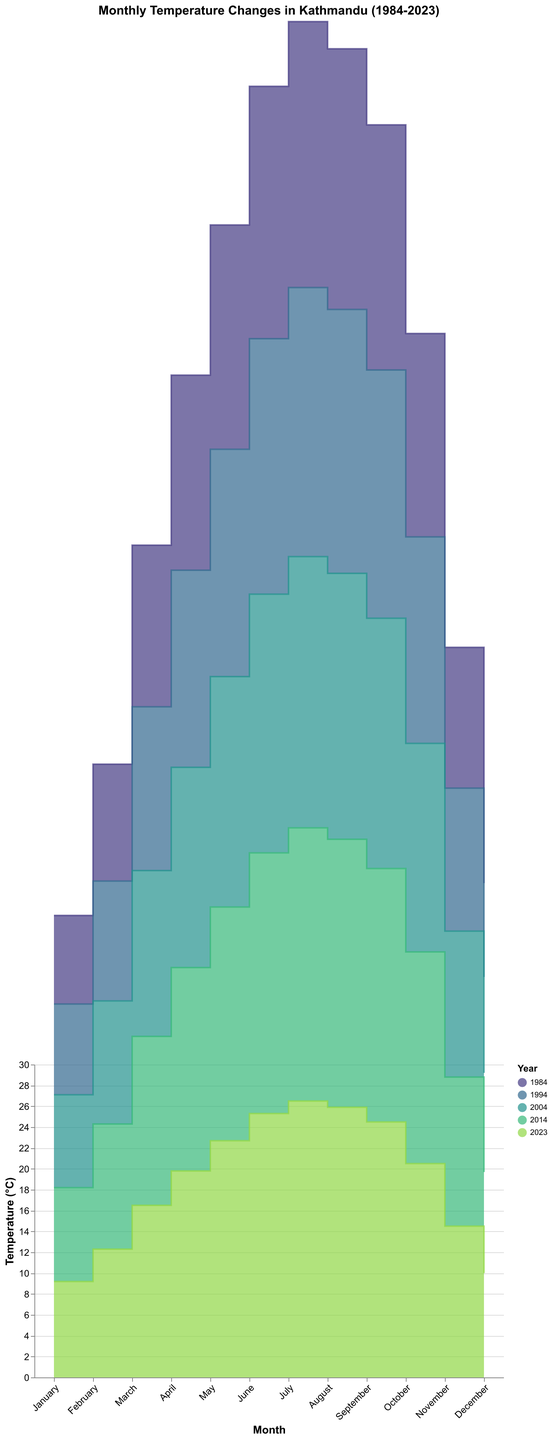What is the title of the figure? The title is visible at the top of the chart and is written in bold, indicating the main theme of the figure. The title reads "Monthly Temperature Changes in Kathmandu (1984-2023)".
Answer: Monthly Temperature Changes in Kathmandu (1984-2023) Which month in 2023 had the highest average temperature? By visually inspecting the step area for the year 2023 and looking for the peak point, we see that July had the highest temperature.
Answer: July How does the temperature in January 1984 compare to January 2023? To compare, locate the data points for January of both years. January 1984 shows 8.5°C, while January 2023 shows 9.2°C. January 2023 is warmer than January 1984.
Answer: 2023 is warmer What is the trend in temperature changes from January to December in 2014? Track the step area for the year 2014 from January to December. The temperature increases until July and then decreases, forming an upward then downward trend.
Answer: Increases then decreases What is the difference in temperature between February 2004 and February 2023? Look at the y-axis values corresponding to February 2004 and February 2023. February 2004 is 11.8°C and February 2023 is 12.3°C, making the difference 0.5°C.
Answer: 0.5°C How consistent are the temperature changes in March over the years? Inspecting the step areas for March across different years show slight increases year by year. The March temperatures range incrementally from 15.5°C in 1984 to 16.5°C in 2023.
Answer: Slight increase Which month typically records the warmest temperatures? By examining the peaks of the step areas for each year, July consistently appears as the warmest month each year.
Answer: July What is the average temperature for June across all provided years? Add the temperatures for June (24.2 in 1984, 24.5 in 1994, 24.8 in 2004, 25.0 in 2014, 25.3 in 2023) and divide by the number of years (5). The sum is 123.8 and the average is 123.8/5 = 24.76.
Answer: 24.76°C How do the temperatures in November 1984 and November 2014 compare? Find November 1984 at 13.5°C and November 2014 at 14.3°C. November 2014 is warmer by 0.8°C.
Answer: 2014 is warmer What is the temperature pattern in April over the four decades? Examine the April data points: slight increasing trend. Temperatures are 18.7°C (1984), 18.9°C (1994), 19.2°C (2004), 19.5°C (2014), and 19.8°C (2023).
Answer: Slightly increasing trend 